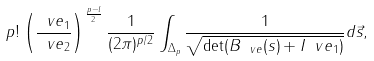<formula> <loc_0><loc_0><loc_500><loc_500>p ! \left ( \frac { \ v e _ { 1 } } { \ v e _ { 2 } } \right ) ^ { \frac { p - l } { 2 } } \frac { 1 } { ( 2 \pi ) ^ { p / 2 } } \int _ { \Delta _ { p } } \frac { 1 } { \sqrt { \det ( B _ { \ v e } ( s ) + I \ v e _ { 1 } ) } } d \vec { s } ,</formula> 